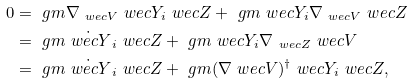<formula> <loc_0><loc_0><loc_500><loc_500>0 & = \ g m { \nabla _ { \ w e c { V } } \ w e c { Y } _ { i } } { \ w e c { Z } } + \ g m { \ w e c { Y } _ { i } } { \nabla _ { \ w e c { V } } \ w e c { Z } } \\ & = \ g m { \dot { \ w e c { Y } } _ { i } } { \ w e c { Z } } + \ g m { \ w e c { Y } _ { i } } { \nabla _ { \ w e c { Z } } \ w e c { V } } \\ & = \ g m { \dot { \ w e c { Y } } _ { i } } { \ w e c { Z } } + \ g m { ( \nabla \ w e c { V } ) ^ { \dag } \ w e c { Y } _ { i } } { \ w e c { Z } } ,</formula> 